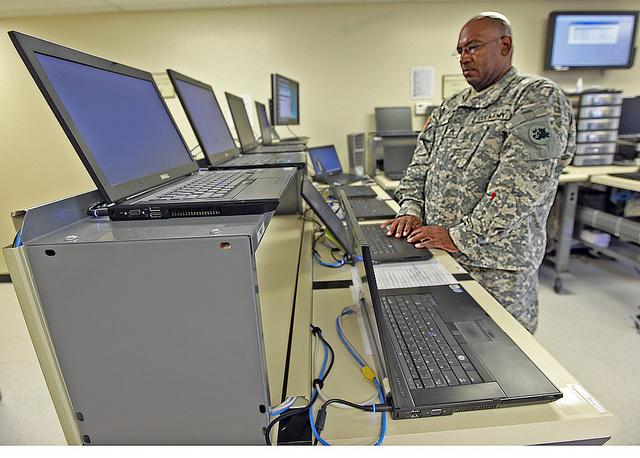Are the screens on?
Short answer required. Yes. Is the man wearing glasses?
Short answer required. Yes. What branch of the military is the man from?
Concise answer only. Army. 